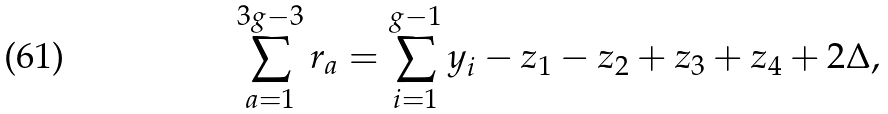Convert formula to latex. <formula><loc_0><loc_0><loc_500><loc_500>\sum _ { a = 1 } ^ { 3 g - 3 } r _ { a } = \sum _ { i = 1 } ^ { g - 1 } y _ { i } - z _ { 1 } - z _ { 2 } + z _ { 3 } + z _ { 4 } + 2 \Delta ,</formula> 